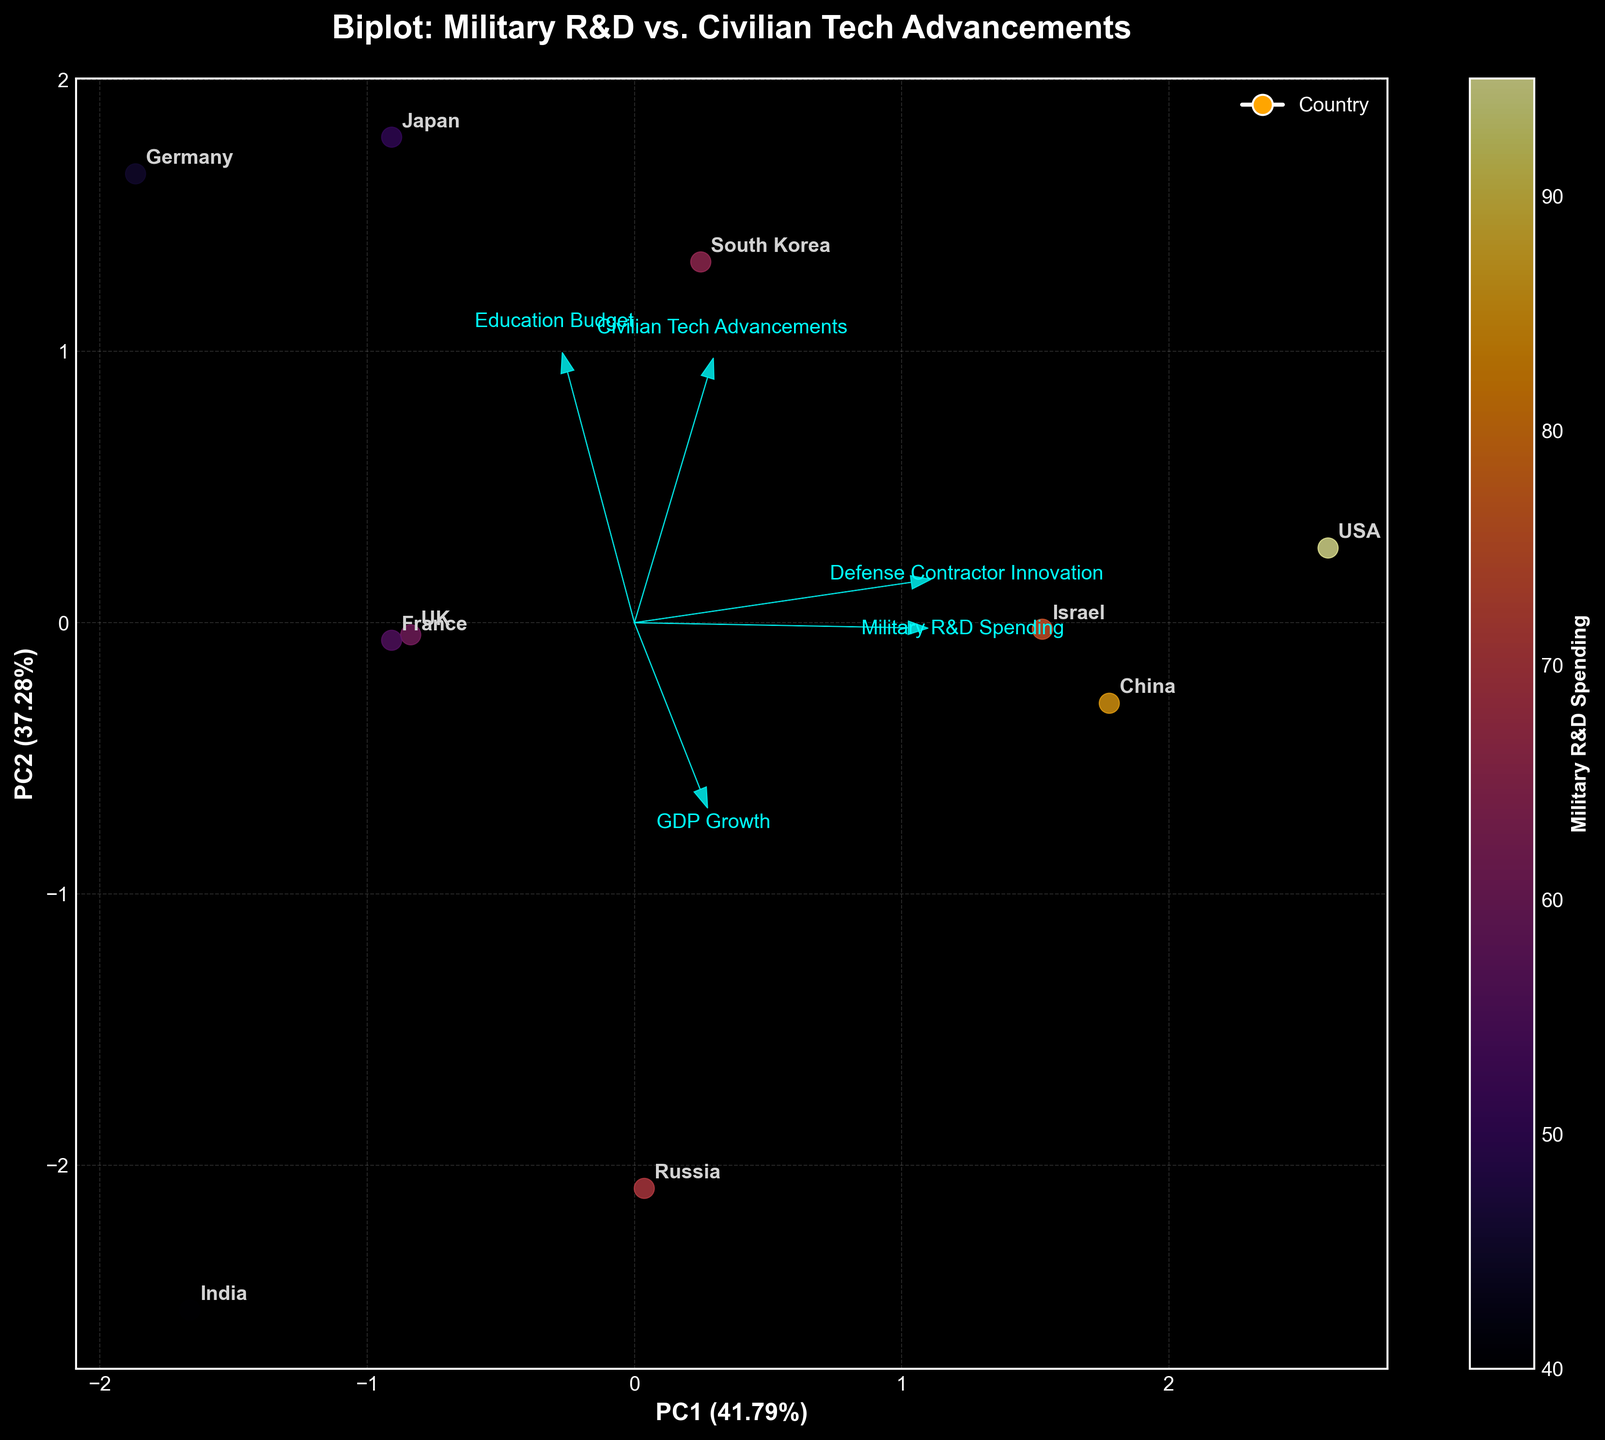What is the title of the figure? The title of the figure is written clearly at the top of the plot. It reads "Biplot: Military R&D vs. Civilian Tech Advancements"
Answer: Biplot: Military R&D vs. Civilian Tech Advancements How are the countries visually differentiated on the plot? Countries are represented as points which are annotated with their names. The points vary in position, indicating their scores on the principal components, and are colored according to their Military R&D Spending values, as indicated by the color bar.
Answer: Different colors and positions Which axis has a higher percentage of explained variance? The explained variance percentages are available in the axis labels. The x-axis, labeled "PC1," accounts for a greater percentage of the variance compared to the y-axis, labeled "PC2".
Answer: The x-axis (PC1) Which country appears closest to the origin in the biplot? By looking at the scatter plot, the country closest to the point where the x-axis and y-axis intersect (the origin) is Russia.
Answer: Russia Based on the biplot, which country's data point shows the highest Military R&D Spending? The color of the points indicates Military R&D Spending. The point with the deepest color (closest to the top end of the color bar) belongs to the USA.
Answer: USA How does Israel compare to Japan in terms of Civilian Tech Advancements according to the biplot? Look at where Israel and Japan are positioned in relation to the arrow representing "Civilian Tech Advancements". Japan is further in the direction of this arrow compared to Israel, indicating higher values.
Answer: Japan has higher Civilian Tech Advancements What is the relationship between Military R&D Spending and Education Budget in this plot? Check the direction and length of the arrows for "Military R&D Spending" and "Education Budget". The arrows point in generally different directions (not parallel), showing that these variables are not strongly correlated.
Answer: They are not strongly correlated Which feature has the smallest contribution to the Principal Component 1 (PC1)? The magnitude of the projections of the arrows on PC1 determines their contribution. The "GDP Growth" arrow is smallest in the direction of PC1, so it contributes the least.
Answer: GDP Growth What countries are positioned in the same quadrant as the USA? Identify the quadrant where the USA is located, and then find the other countries in that same area. Germany, Russia, and France are in the same quadrant as the USA.
Answer: Germany, Russia, France Does the direction of the "Defense Contractor Innovation" arrow indicate a positive or negative correlation with PC1? Since the "Defense Contractor Innovation" arrow points to the right, along the positively direction of PC1, this indicates a positive correlation with PC1.
Answer: Positive 